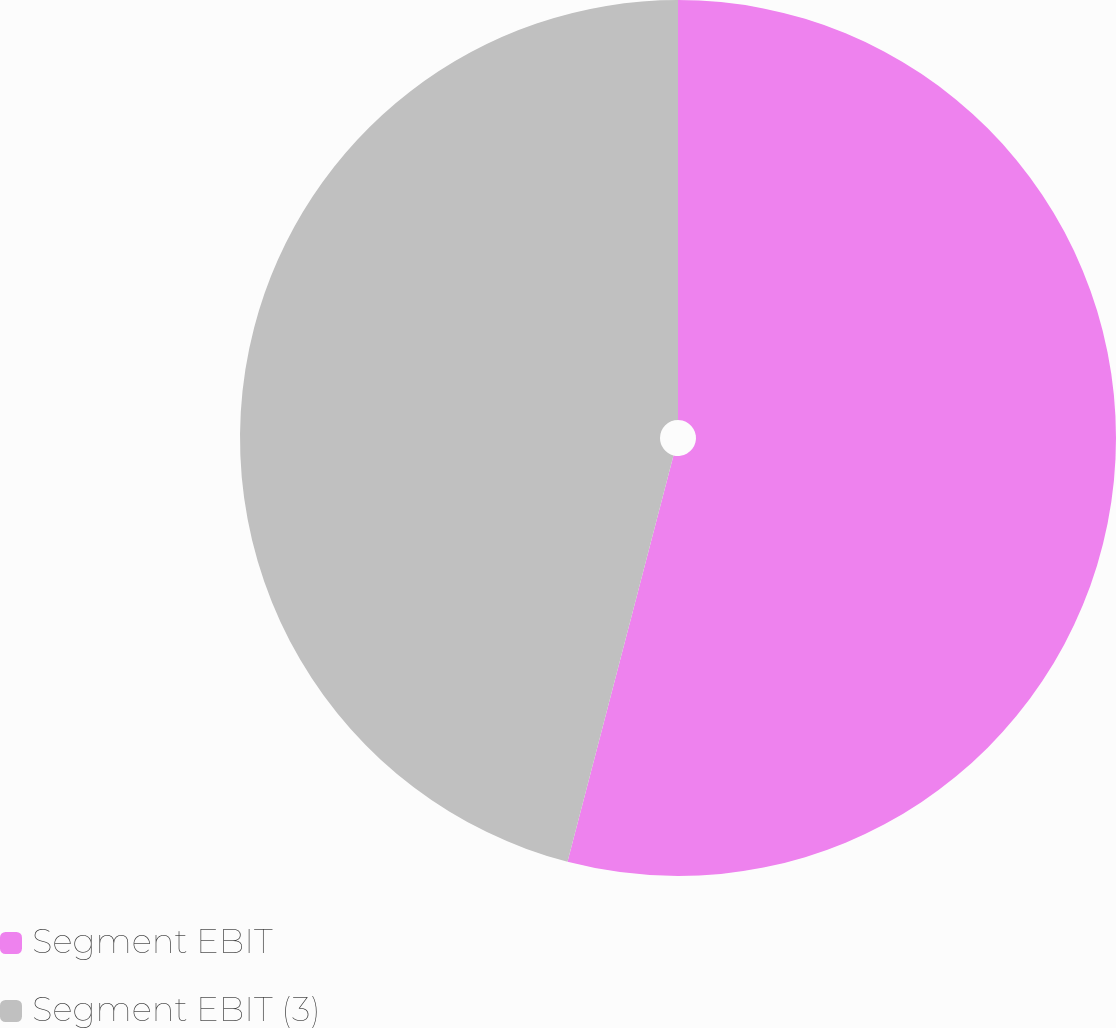Convert chart. <chart><loc_0><loc_0><loc_500><loc_500><pie_chart><fcel>Segment EBIT<fcel>Segment EBIT (3)<nl><fcel>54.06%<fcel>45.94%<nl></chart> 